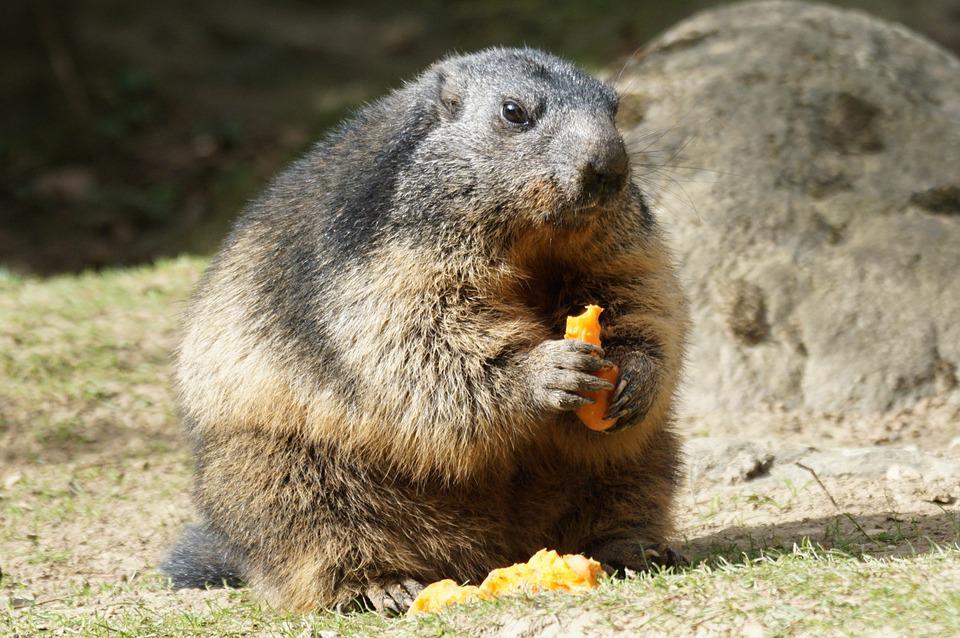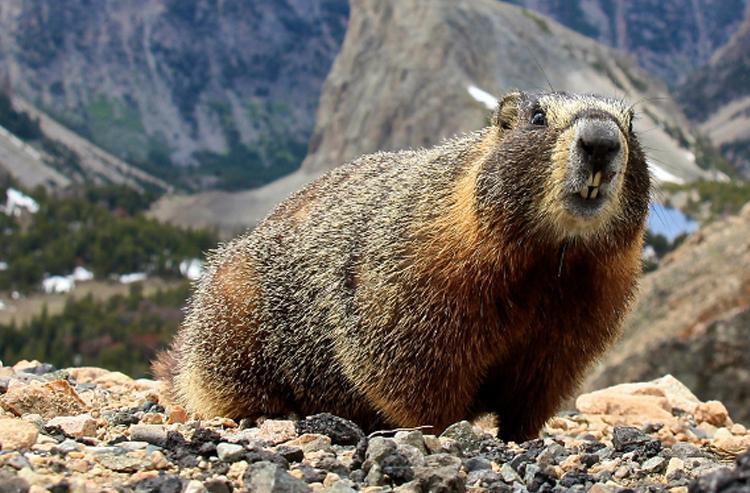The first image is the image on the left, the second image is the image on the right. Considering the images on both sides, is "One imag shows a single marmot with hands together lifted in front of its body." valid? Answer yes or no. Yes. The first image is the image on the left, the second image is the image on the right. For the images displayed, is the sentence "Two animals are on a rocky ledge." factually correct? Answer yes or no. No. 